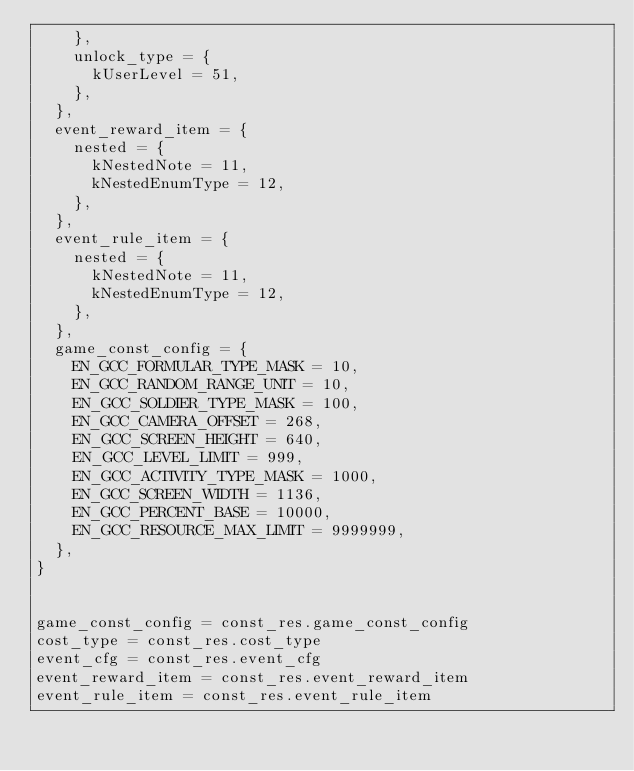<code> <loc_0><loc_0><loc_500><loc_500><_Lua_>    },
    unlock_type = {
      kUserLevel = 51,
    },
  },
  event_reward_item = {
    nested = {
      kNestedNote = 11,
      kNestedEnumType = 12,
    },
  },
  event_rule_item = {
    nested = {
      kNestedNote = 11,
      kNestedEnumType = 12,
    },
  },
  game_const_config = {
    EN_GCC_FORMULAR_TYPE_MASK = 10,
    EN_GCC_RANDOM_RANGE_UNIT = 10,
    EN_GCC_SOLDIER_TYPE_MASK = 100,
    EN_GCC_CAMERA_OFFSET = 268,
    EN_GCC_SCREEN_HEIGHT = 640,
    EN_GCC_LEVEL_LIMIT = 999,
    EN_GCC_ACTIVITY_TYPE_MASK = 1000,
    EN_GCC_SCREEN_WIDTH = 1136,
    EN_GCC_PERCENT_BASE = 10000,
    EN_GCC_RESOURCE_MAX_LIMIT = 9999999,
  },
}


game_const_config = const_res.game_const_config
cost_type = const_res.cost_type
event_cfg = const_res.event_cfg
event_reward_item = const_res.event_reward_item
event_rule_item = const_res.event_rule_item
</code> 